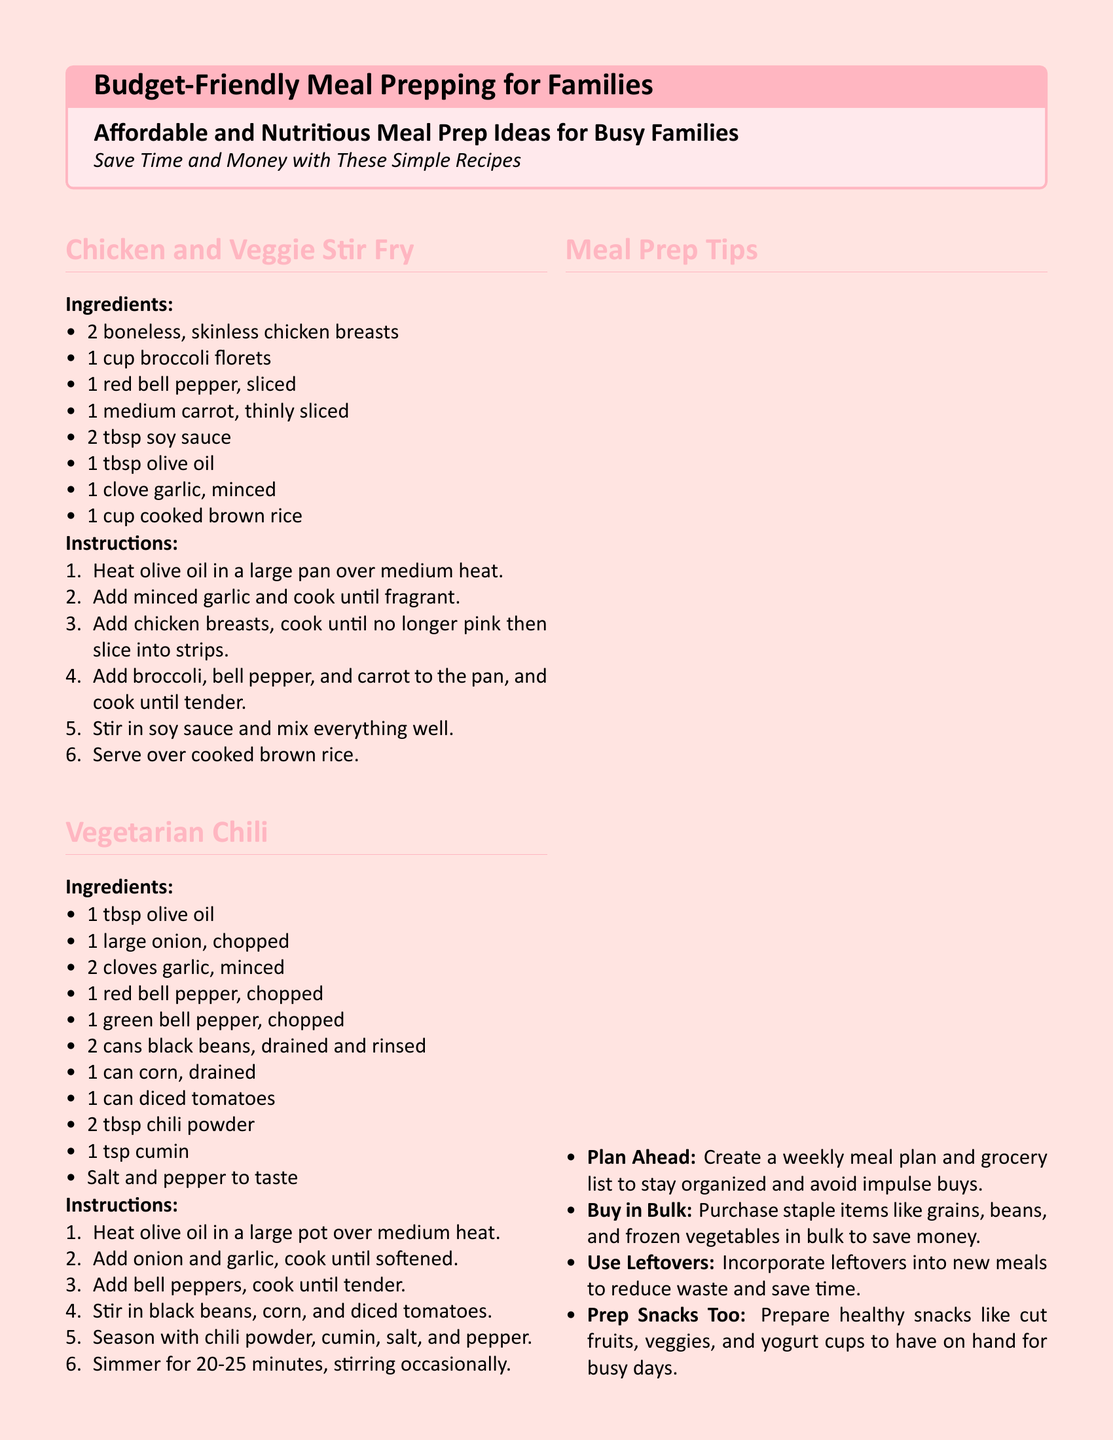What is the title of the document? The title of the document is presented at the beginning, emphasizing the main topic of budget-friendly meal prep.
Answer: Budget-Friendly Meal Prepping for Families How many ingredients are listed for the Chicken and Veggie Stir Fry? The count of ingredients for this recipe is found by counting the items in the ingredients list.
Answer: 8 What cooking method is used for the Overnight Oats? The method is indicated in the instructions, specifying how the dish is prepared.
Answer: Refrigerate What is the main protein source in the Turkey and Cheese Wraps? The main protein is identified by looking at the main ingredient in the recipe for the wraps.
Answer: Turkey How long does the Vegetarian Chili need to simmer? The simmering time is specified in the instructions for the vegetarian chili.
Answer: 20-25 minutes What type of meal preparation tips are suggested in the document? The tips provided are related to organization, budgeting, and reducing waste, reflecting the overall goal of meal prepping.
Answer: Plan Ahead What is the flavoring ingredient used in both the Chicken and Veggie Stir Fry and Vegetarian Chili? This ingredient is common in both recipes for adding taste and flavor.
Answer: Garlic How many whole wheat tortillas are needed for the Turkey and Cheese Wraps? The number of tortillas is provided in the ingredients list for this meal.
Answer: 4 